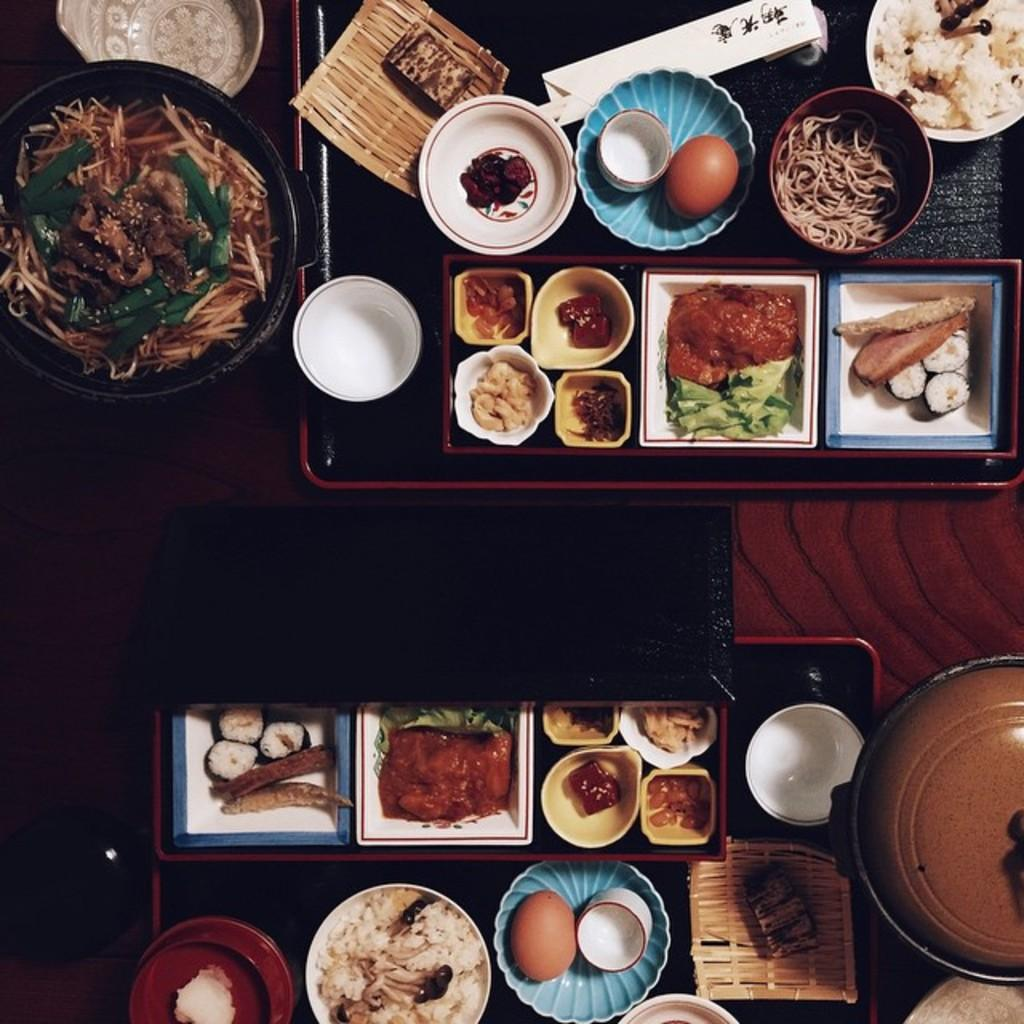What is present on the table in the image? There are food items on the table in the image. Can you see a crown on the table in the image? No, there is no crown present on the table in the image. 